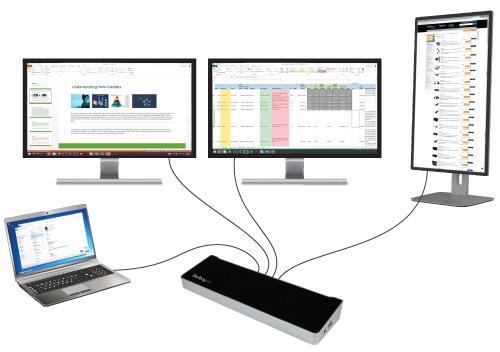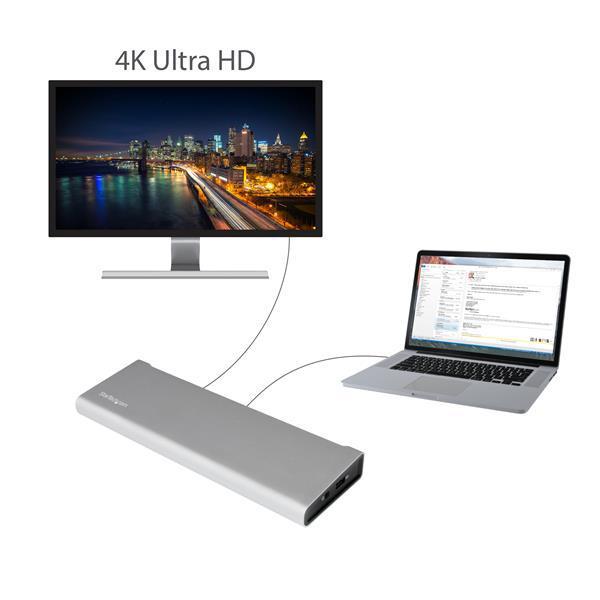The first image is the image on the left, the second image is the image on the right. Considering the images on both sides, is "there is a monitor with a keyboard in front of it and a mouse to the right of the keyboard" valid? Answer yes or no. No. 